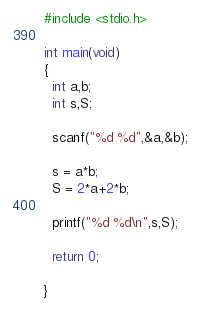Convert code to text. <code><loc_0><loc_0><loc_500><loc_500><_C_>#include <stdio.h>

int main(void)
{
  int a,b;
  int s,S;

  scanf("%d %d",&a,&b);

  s = a*b;
  S = 2*a+2*b;

  printf("%d %d\n",s,S);

  return 0;

}

</code> 